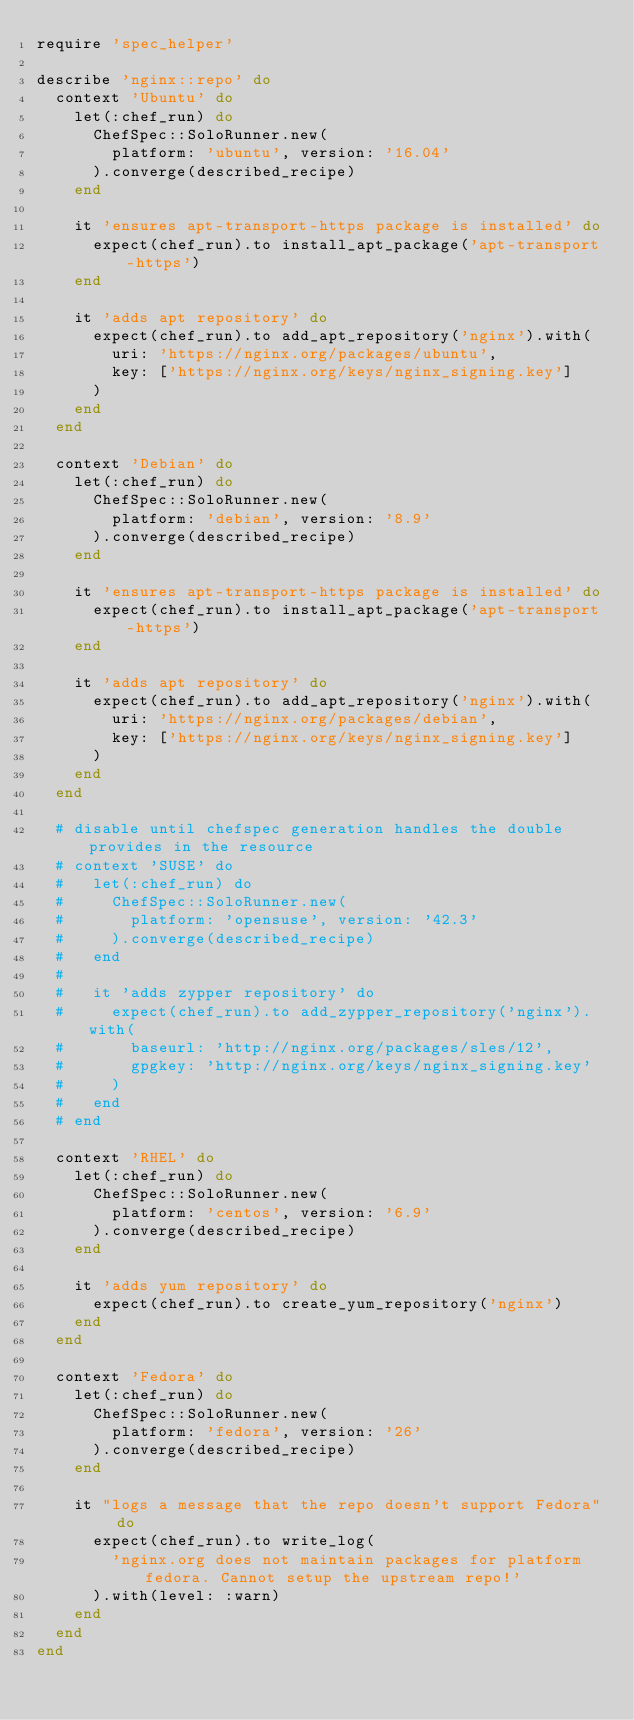<code> <loc_0><loc_0><loc_500><loc_500><_Ruby_>require 'spec_helper'

describe 'nginx::repo' do
  context 'Ubuntu' do
    let(:chef_run) do
      ChefSpec::SoloRunner.new(
        platform: 'ubuntu', version: '16.04'
      ).converge(described_recipe)
    end

    it 'ensures apt-transport-https package is installed' do
      expect(chef_run).to install_apt_package('apt-transport-https')
    end

    it 'adds apt repository' do
      expect(chef_run).to add_apt_repository('nginx').with(
        uri: 'https://nginx.org/packages/ubuntu',
        key: ['https://nginx.org/keys/nginx_signing.key']
      )
    end
  end

  context 'Debian' do
    let(:chef_run) do
      ChefSpec::SoloRunner.new(
        platform: 'debian', version: '8.9'
      ).converge(described_recipe)
    end

    it 'ensures apt-transport-https package is installed' do
      expect(chef_run).to install_apt_package('apt-transport-https')
    end

    it 'adds apt repository' do
      expect(chef_run).to add_apt_repository('nginx').with(
        uri: 'https://nginx.org/packages/debian',
        key: ['https://nginx.org/keys/nginx_signing.key']
      )
    end
  end

  # disable until chefspec generation handles the double provides in the resource
  # context 'SUSE' do
  #   let(:chef_run) do
  #     ChefSpec::SoloRunner.new(
  #       platform: 'opensuse', version: '42.3'
  #     ).converge(described_recipe)
  #   end
  #
  #   it 'adds zypper repository' do
  #     expect(chef_run).to add_zypper_repository('nginx').with(
  #       baseurl: 'http://nginx.org/packages/sles/12',
  #       gpgkey: 'http://nginx.org/keys/nginx_signing.key'
  #     )
  #   end
  # end

  context 'RHEL' do
    let(:chef_run) do
      ChefSpec::SoloRunner.new(
        platform: 'centos', version: '6.9'
      ).converge(described_recipe)
    end

    it 'adds yum repository' do
      expect(chef_run).to create_yum_repository('nginx')
    end
  end

  context 'Fedora' do
    let(:chef_run) do
      ChefSpec::SoloRunner.new(
        platform: 'fedora', version: '26'
      ).converge(described_recipe)
    end

    it "logs a message that the repo doesn't support Fedora" do
      expect(chef_run).to write_log(
        'nginx.org does not maintain packages for platform fedora. Cannot setup the upstream repo!'
      ).with(level: :warn)
    end
  end
end
</code> 